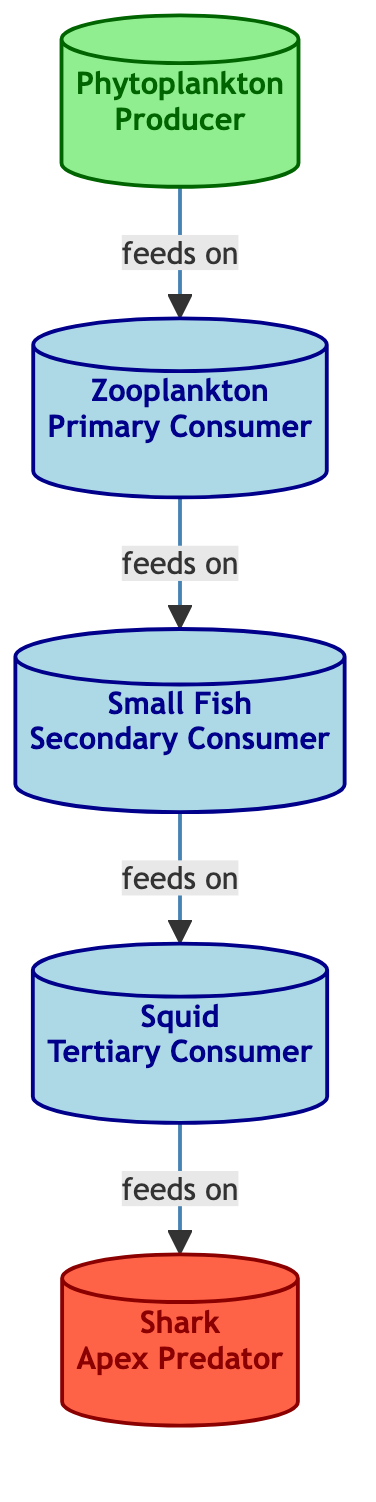What is the producer in the food web? The diagram identifies "Phytoplankton" as the producer category, which is the first node in the flowchart.
Answer: Phytoplankton How many consumer levels are there in the diagram? The flowchart shows three distinct consumer levels: Zooplankton (primary), Small Fish (secondary), and Squid (tertiary), creating a total of three consumer levels.
Answer: 3 What does the Squid feed on? According to the diagram, the Squid is classified as a tertiary consumer that feeds on Small Fish, which is indicated by the directed arrow leading from Small Fish to Squid.
Answer: Small Fish Who is the apex predator in the food web? The diagram specifies "Shark" as the apex predator, as it is the final node and is not preyed upon by any other species in this flowchart.
Answer: Shark How many total nodes are there in this food web? The food web comprises five total nodes, which include Phytoplankton, Zooplankton, Small Fish, Squid, and Shark, all represented in the diagram.
Answer: 5 Which organism is located directly below the apex predator? The diagram shows Squid located directly below Shark, indicating the feeding relationship where Squid is prey for the Shark.
Answer: Squid What type of interactions are represented between the different nodes? The diagram illustrates a feeding relationship where producers and consumers are linked by arrows indicating which organism feeds on another, showcasing a food chain dynamic.
Answer: Feeding relationships What is the relationship between Zooplankton and Small Fish? The diagram indicates a direct relationship where Zooplankton, categorized as a primary consumer, feeds on Small Fish, which is a secondary consumer.
Answer: Zooplankton feeds on Small Fish 